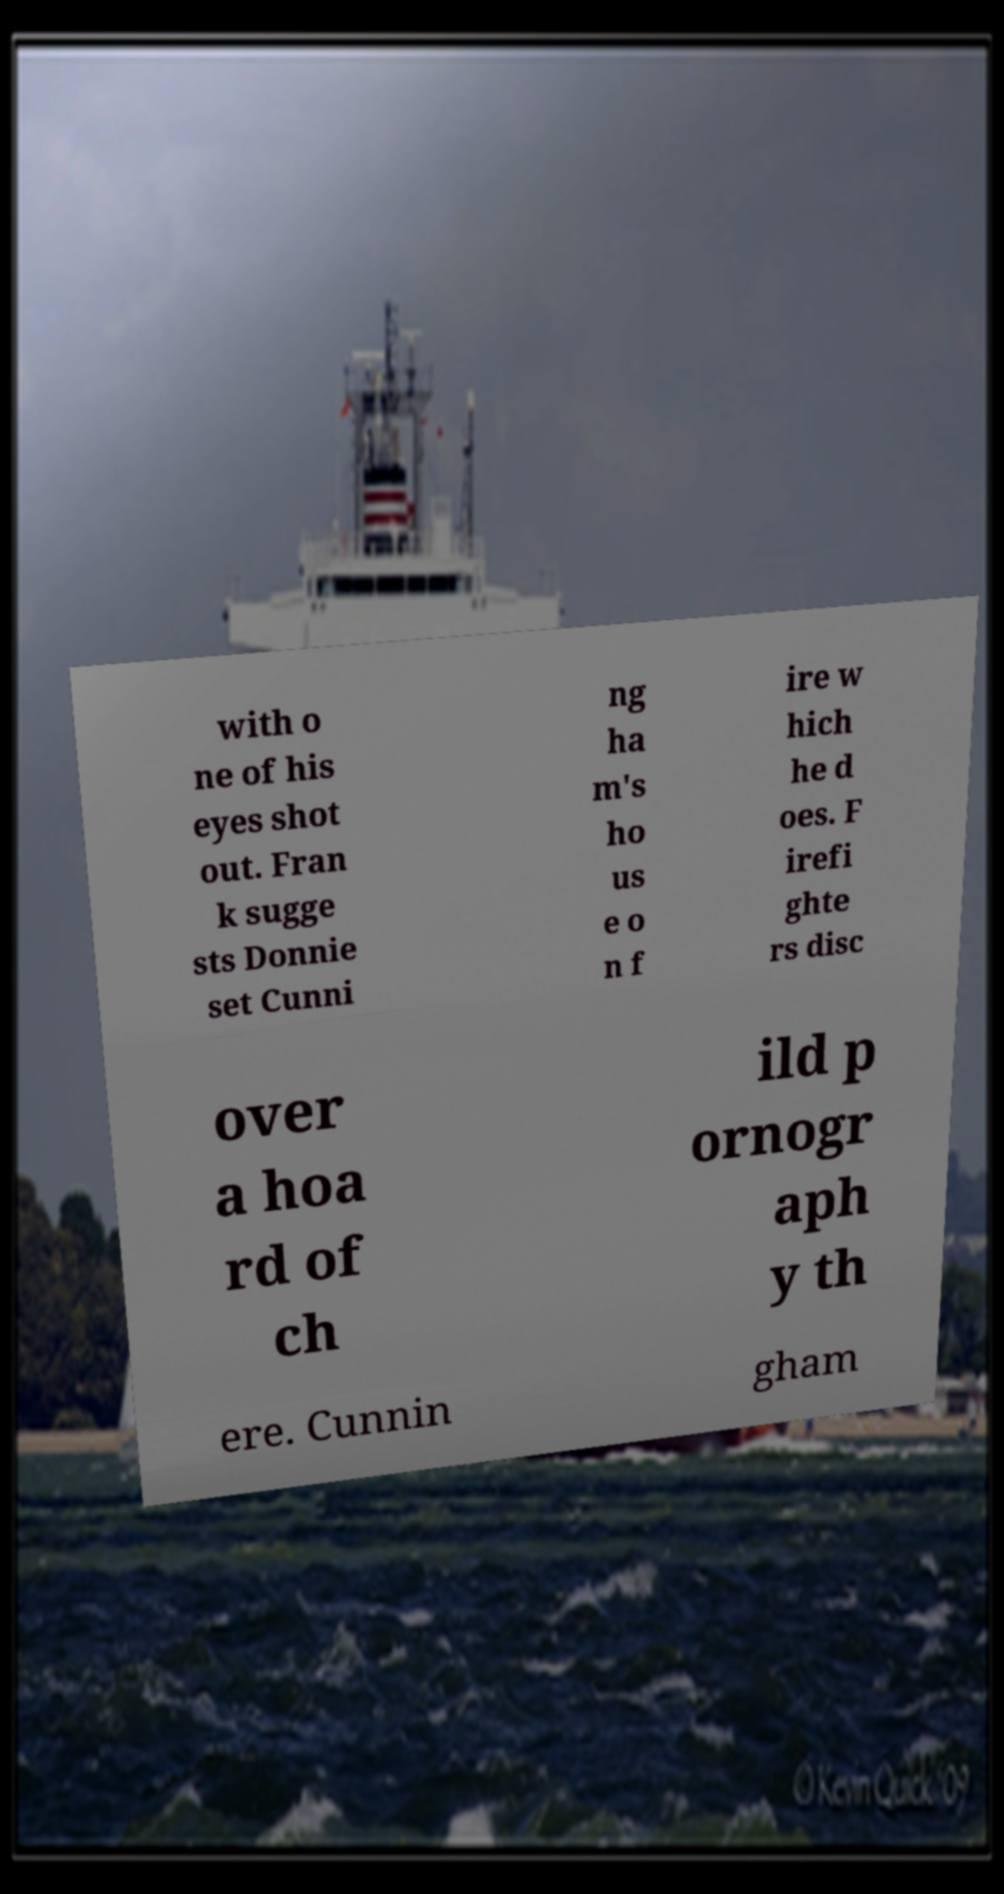Can you accurately transcribe the text from the provided image for me? with o ne of his eyes shot out. Fran k sugge sts Donnie set Cunni ng ha m's ho us e o n f ire w hich he d oes. F irefi ghte rs disc over a hoa rd of ch ild p ornogr aph y th ere. Cunnin gham 